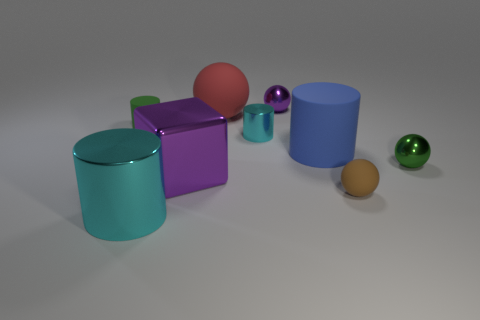Subtract 1 cylinders. How many cylinders are left? 3 Add 1 red rubber things. How many objects exist? 10 Subtract all spheres. How many objects are left? 5 Add 1 big cyan shiny objects. How many big cyan shiny objects are left? 2 Add 3 large green rubber cubes. How many large green rubber cubes exist? 3 Subtract 0 yellow cylinders. How many objects are left? 9 Subtract all cyan shiny objects. Subtract all big cyan metal cylinders. How many objects are left? 6 